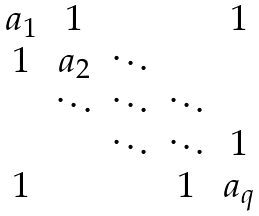Convert formula to latex. <formula><loc_0><loc_0><loc_500><loc_500>\begin{matrix} a _ { 1 } & 1 & & & 1 \\ 1 & a _ { 2 } & \ddots & & \\ & \ddots & \ddots & \ddots & \\ & & \ddots & \ddots & 1 \\ 1 & & & 1 & a _ { q } \\ \end{matrix}</formula> 